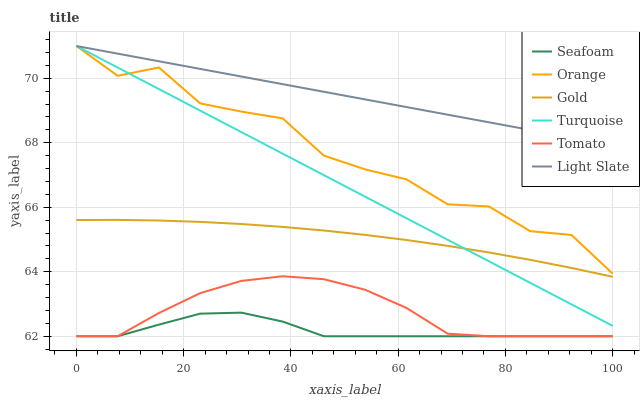Does Seafoam have the minimum area under the curve?
Answer yes or no. Yes. Does Light Slate have the maximum area under the curve?
Answer yes or no. Yes. Does Turquoise have the minimum area under the curve?
Answer yes or no. No. Does Turquoise have the maximum area under the curve?
Answer yes or no. No. Is Turquoise the smoothest?
Answer yes or no. Yes. Is Orange the roughest?
Answer yes or no. Yes. Is Gold the smoothest?
Answer yes or no. No. Is Gold the roughest?
Answer yes or no. No. Does Turquoise have the lowest value?
Answer yes or no. No. Does Gold have the highest value?
Answer yes or no. No. Is Tomato less than Gold?
Answer yes or no. Yes. Is Light Slate greater than Gold?
Answer yes or no. Yes. Does Tomato intersect Gold?
Answer yes or no. No. 